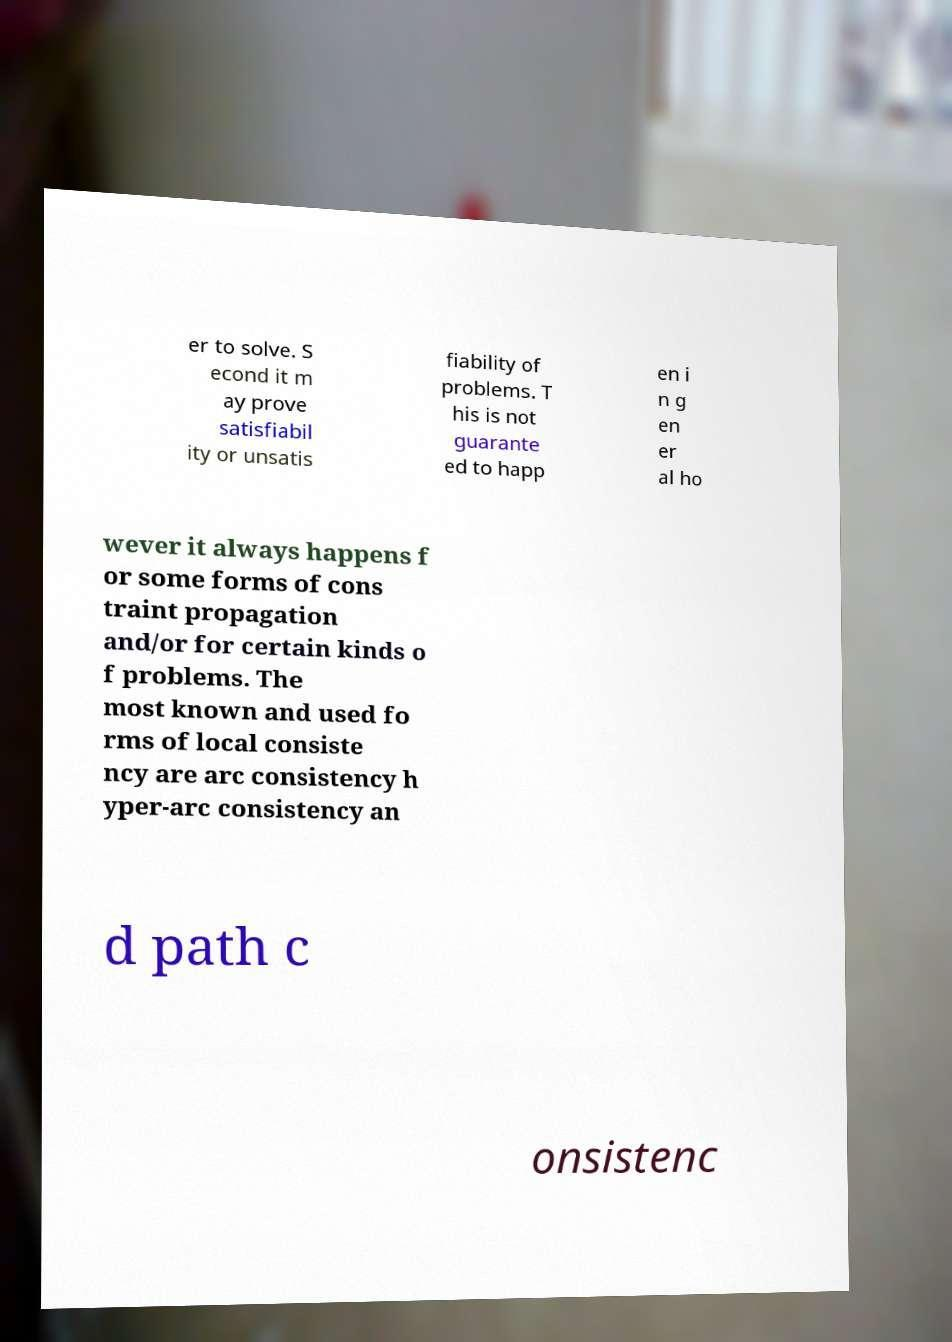Please identify and transcribe the text found in this image. er to solve. S econd it m ay prove satisfiabil ity or unsatis fiability of problems. T his is not guarante ed to happ en i n g en er al ho wever it always happens f or some forms of cons traint propagation and/or for certain kinds o f problems. The most known and used fo rms of local consiste ncy are arc consistency h yper-arc consistency an d path c onsistenc 